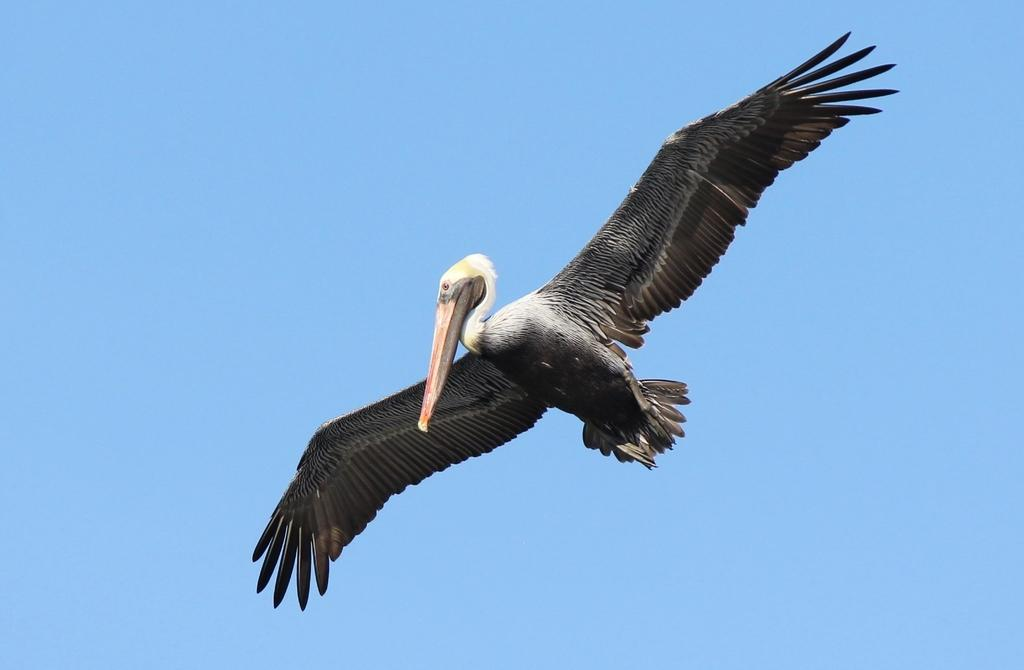What type of animal can be seen in the image? There is a bird in the image. What is the bird doing in the image? The bird is flying in the air. What can be seen above the bird in the image? The sky is visible above the bird. How does the bird's breath affect the wax in the image? There is no wax present in the image, so the bird's breath cannot affect any wax. 